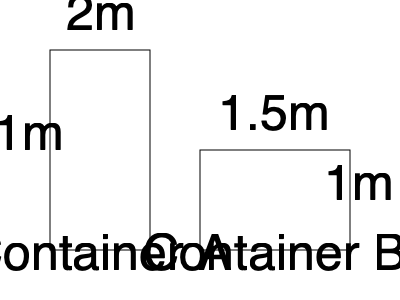A hospital is considering two types of medical supply containers for their renovation project. Container A measures 1m x 1m x 2m, while Container B measures 1.5m x 1m x 1m. If the hospital needs to store 3000 liters of supplies, how many of each container type would be required, and which option would be more cost-effective if Container A costs $500 and Container B costs $400? 1. Calculate the volume of each container:
   Container A: $V_A = 1m \times 1m \times 2m = 2m^3 = 2000$ liters
   Container B: $V_B = 1.5m \times 1m \times 1m = 1.5m^3 = 1500$ liters

2. Calculate the number of containers needed for 3000 liters:
   Container A: $3000 \div 2000 = 1.5$, round up to 2 containers
   Container B: $3000 \div 1500 = 2$ containers

3. Calculate the total cost for each option:
   Container A: $2 \times \$500 = \$1000$
   Container B: $2 \times \$400 = \$800$

4. Compare costs and storage capacity:
   Container A: 2 containers provide 4000 liters for $1000
   Container B: 2 containers provide 3000 liters for $800

5. Analyze cost-effectiveness:
   Container B is more cost-effective as it provides the exact required storage capacity (3000 liters) at a lower total cost ($800 vs $1000).
Answer: 2 of Container B at $800 total 